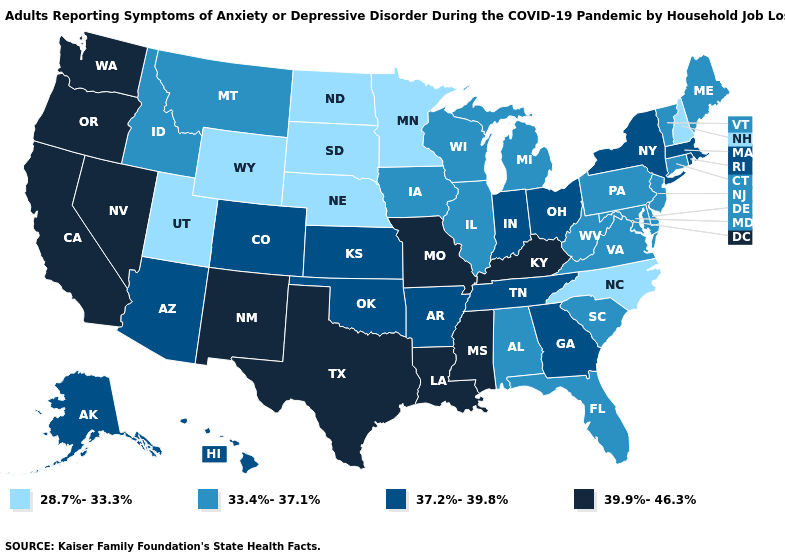What is the value of Alaska?
Answer briefly. 37.2%-39.8%. Which states have the highest value in the USA?
Write a very short answer. California, Kentucky, Louisiana, Mississippi, Missouri, Nevada, New Mexico, Oregon, Texas, Washington. Among the states that border Vermont , which have the highest value?
Short answer required. Massachusetts, New York. What is the highest value in the USA?
Give a very brief answer. 39.9%-46.3%. Name the states that have a value in the range 37.2%-39.8%?
Answer briefly. Alaska, Arizona, Arkansas, Colorado, Georgia, Hawaii, Indiana, Kansas, Massachusetts, New York, Ohio, Oklahoma, Rhode Island, Tennessee. Does New Hampshire have the highest value in the Northeast?
Be succinct. No. Does the map have missing data?
Keep it brief. No. Does Georgia have a lower value than Missouri?
Short answer required. Yes. What is the value of New Hampshire?
Answer briefly. 28.7%-33.3%. What is the highest value in the Northeast ?
Quick response, please. 37.2%-39.8%. Among the states that border Arkansas , which have the highest value?
Be succinct. Louisiana, Mississippi, Missouri, Texas. Among the states that border Arkansas , which have the highest value?
Short answer required. Louisiana, Mississippi, Missouri, Texas. What is the lowest value in the West?
Answer briefly. 28.7%-33.3%. Name the states that have a value in the range 39.9%-46.3%?
Give a very brief answer. California, Kentucky, Louisiana, Mississippi, Missouri, Nevada, New Mexico, Oregon, Texas, Washington. Among the states that border West Virginia , which have the highest value?
Answer briefly. Kentucky. 